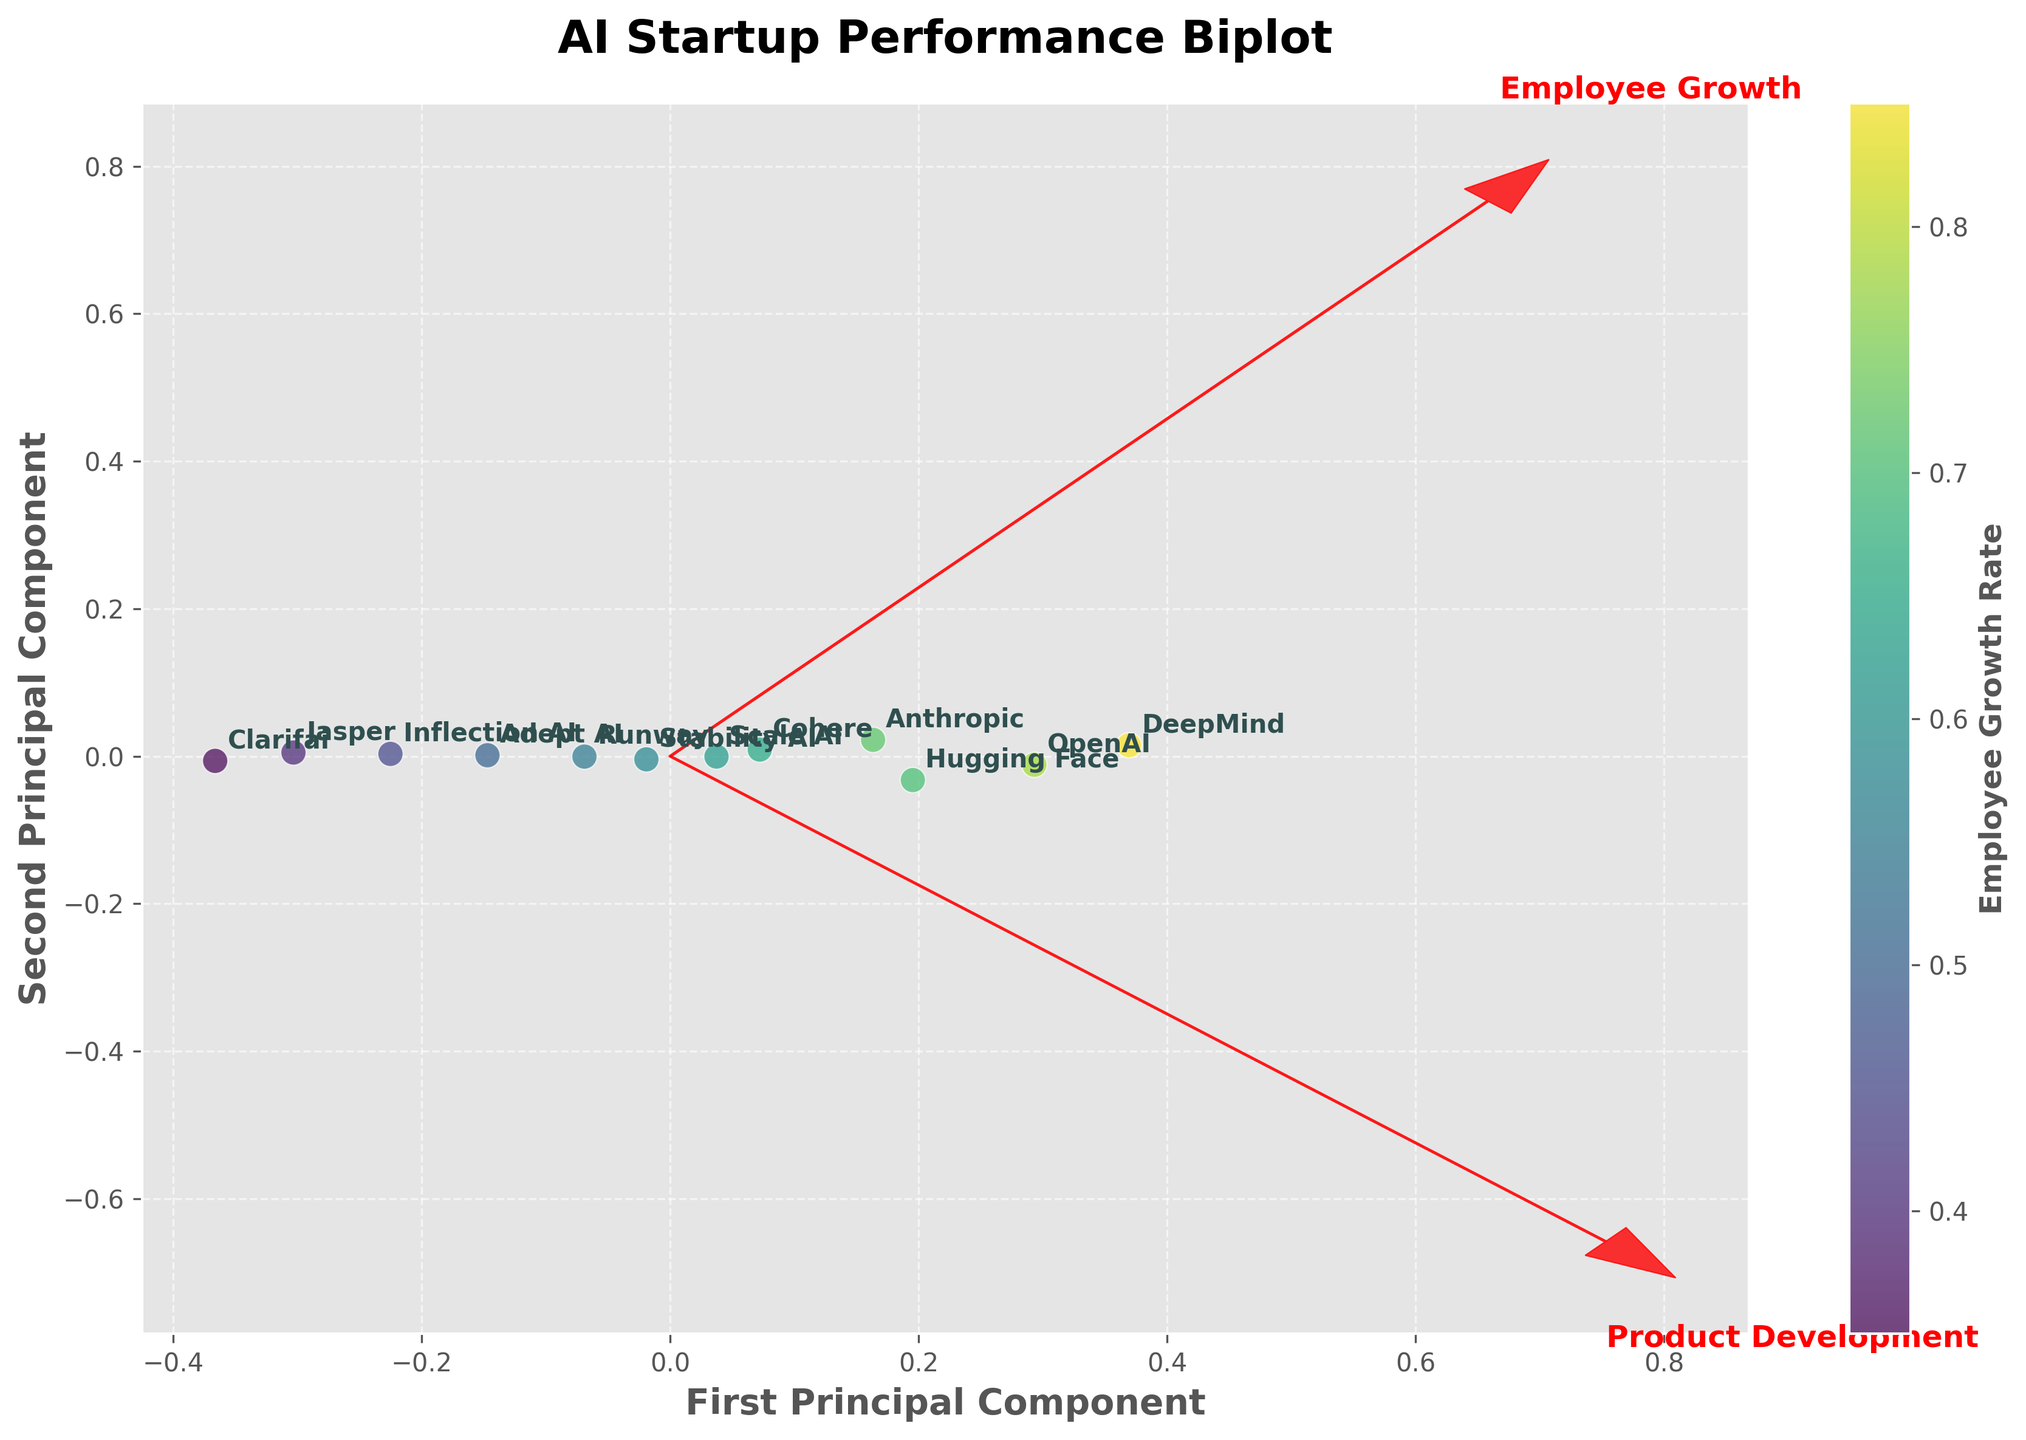What is the title of the figure? The title of the figure can be found at the top of the plot, usually in a larger and bold font. In this case, the title reads "AI Startup Performance Biplot".
Answer: AI Startup Performance Biplot Which company has the highest Employee Growth Rate? The company with the highest Employee Growth Rate will be positioned at the point with the highest value on the color scale, and it is labeled accordingly. Here, DeepMind is positioned at the top of the color scale.
Answer: DeepMind How many companies are represented in the plot? The number of companies can be determined by counting the number of labeled data points. There are twelve labeled data points in the figure, representing twelve companies.
Answer: Twelve Which two companies are closest to each other in the plot? By visually inspecting the distances between labeled data points, we can see that Adept AI and Inflection AI are located closest to each other.
Answer: Adept AI and Inflection AI Which company has the highest Product Development Milestone and where is it positioned in relation to the plot center? The company with the highest Product Development Milestone will be positioned at the point with the highest value along the second principal component (y-axis). DeepMind appears to have the highest Product Development Milestone and is positioned towards the top right of the plot.
Answer: DeepMind How does the vector for Employee Growth relate to the vector for Product Development? The directions of the feature vectors indicate their relative importance and relationship. Here, the vector for Employee Growth points in a different direction compared to Product Development, implying some correlation but not perfect alignment. Both vectors point outward from the origin but in slightly diverging directions.
Answer: Diverging directions What is the relationship between Employee Growth Rate and Product Development Milestone for Jasper? Jasper's point position on the plot is relatively low on both the first and second principal components, indicating both a low Employee Growth Rate and a low Product Development Milestone in comparison to other AI startups.
Answer: Both low Between Anthropic and Hugging Face, which company has a better balance between Employee Growth Rate and Product Development Milestone? By analyzing their positions on the Biplot, we see that Hugging Face is positioned higher and closer to the feature vector for Product Development, as well as moderately placed on Employee Growth, suggesting a better balance between the two metrics.
Answer: Hugging Face 